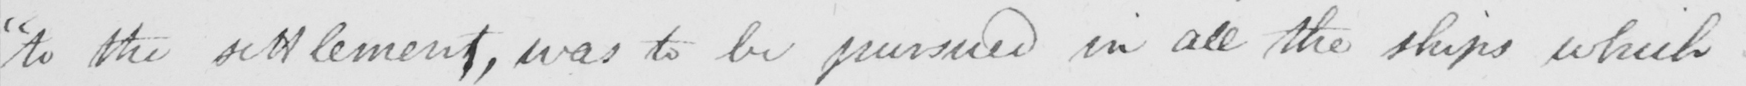What does this handwritten line say? " to the settlement , was to be pursued in all the ships which 